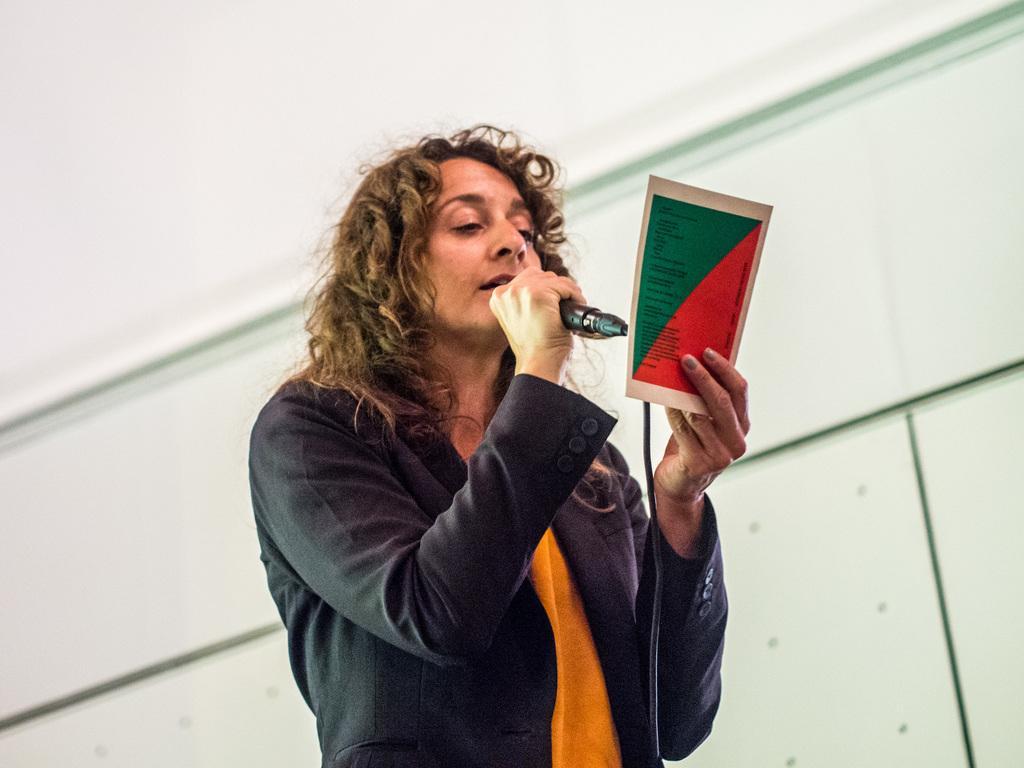Please provide a concise description of this image. In the center of the image we can see a person standing and holding a mic and a paper. In the background there is a wall. 